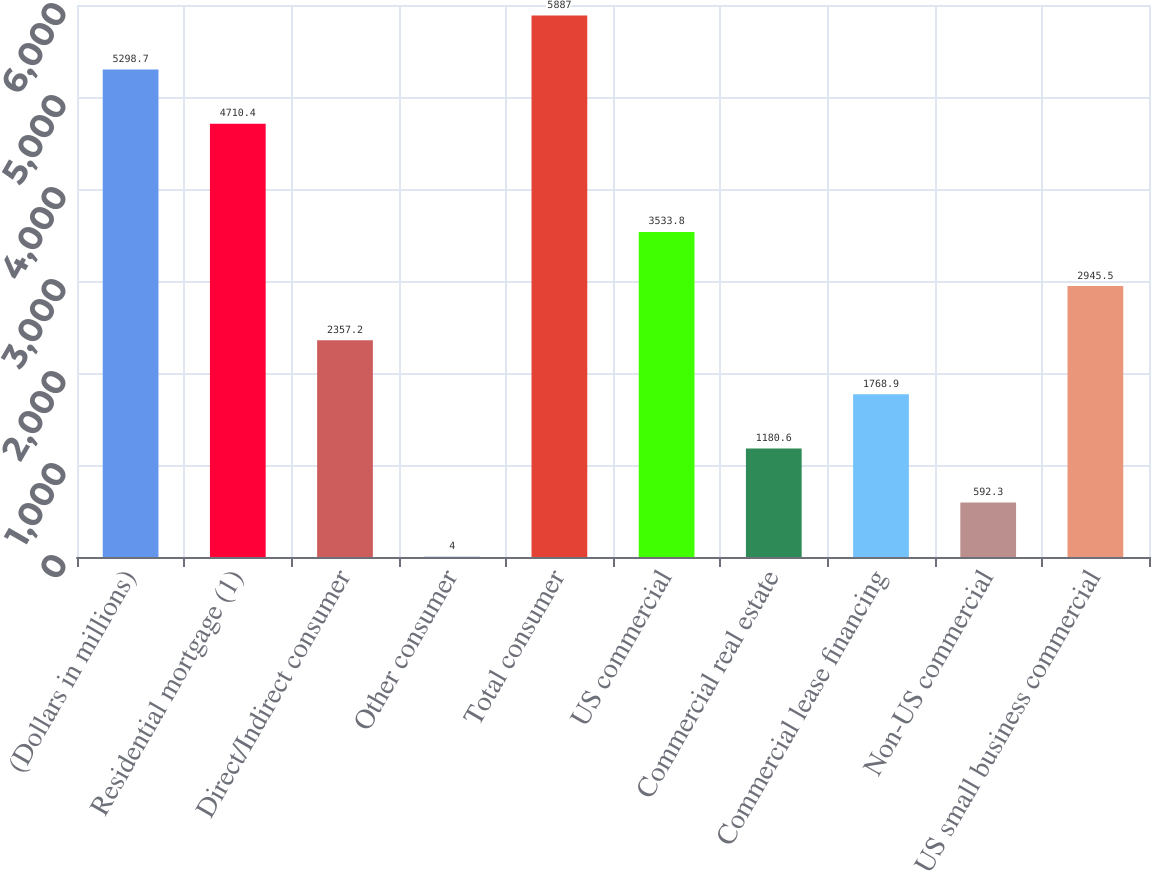Convert chart to OTSL. <chart><loc_0><loc_0><loc_500><loc_500><bar_chart><fcel>(Dollars in millions)<fcel>Residential mortgage (1)<fcel>Direct/Indirect consumer<fcel>Other consumer<fcel>Total consumer<fcel>US commercial<fcel>Commercial real estate<fcel>Commercial lease financing<fcel>Non-US commercial<fcel>US small business commercial<nl><fcel>5298.7<fcel>4710.4<fcel>2357.2<fcel>4<fcel>5887<fcel>3533.8<fcel>1180.6<fcel>1768.9<fcel>592.3<fcel>2945.5<nl></chart> 